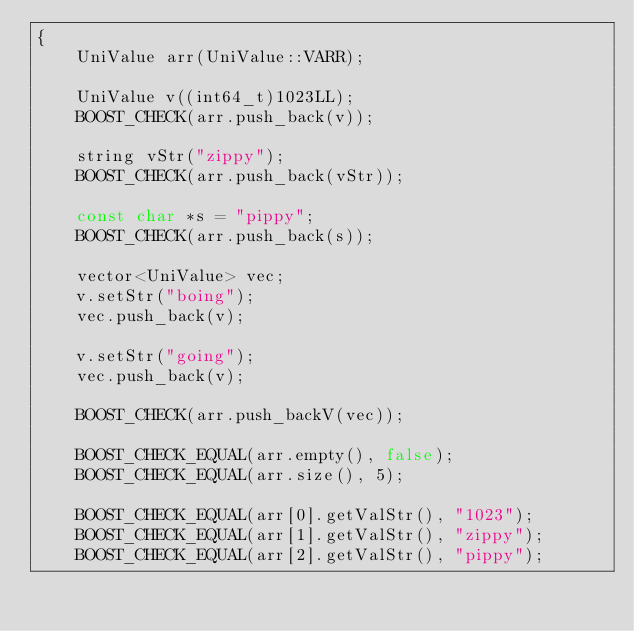<code> <loc_0><loc_0><loc_500><loc_500><_C++_>{
    UniValue arr(UniValue::VARR);

    UniValue v((int64_t)1023LL);
    BOOST_CHECK(arr.push_back(v));

    string vStr("zippy");
    BOOST_CHECK(arr.push_back(vStr));

    const char *s = "pippy";
    BOOST_CHECK(arr.push_back(s));

    vector<UniValue> vec;
    v.setStr("boing");
    vec.push_back(v);

    v.setStr("going");
    vec.push_back(v);

    BOOST_CHECK(arr.push_backV(vec));

    BOOST_CHECK_EQUAL(arr.empty(), false);
    BOOST_CHECK_EQUAL(arr.size(), 5);

    BOOST_CHECK_EQUAL(arr[0].getValStr(), "1023");
    BOOST_CHECK_EQUAL(arr[1].getValStr(), "zippy");
    BOOST_CHECK_EQUAL(arr[2].getValStr(), "pippy");</code> 